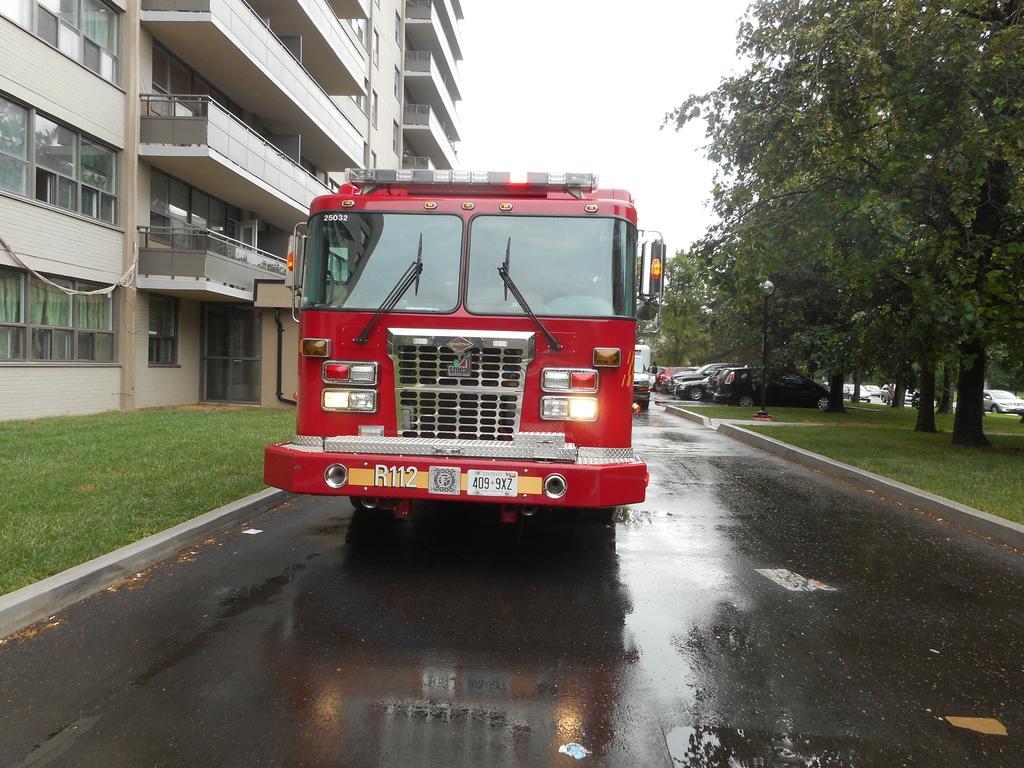How would you summarize this image in a sentence or two? In the image there is a vehicle moving on the road and in the right side some cars are parked beside the garden,there are a lot of trees around that garden,on the left side there is a big building. 